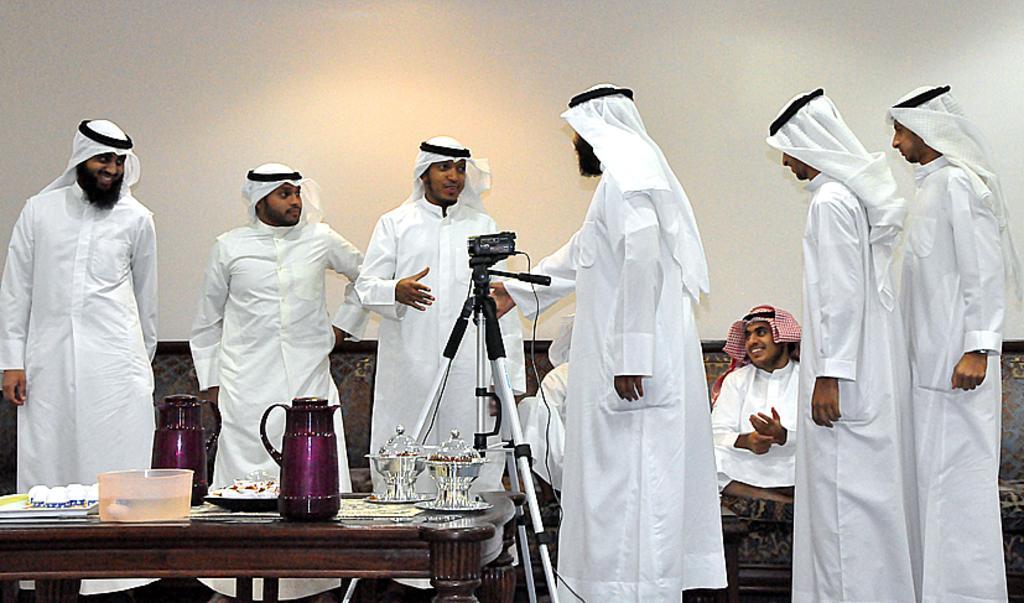Could you give a brief overview of what you see in this image? In the image there are many people , in the middle there is a camera and stand. On the left there is a table on that there is a plate ,box ,jug and some other items. In the background there are two people sitting on the sofa. On the left there is a man he is smiling. 